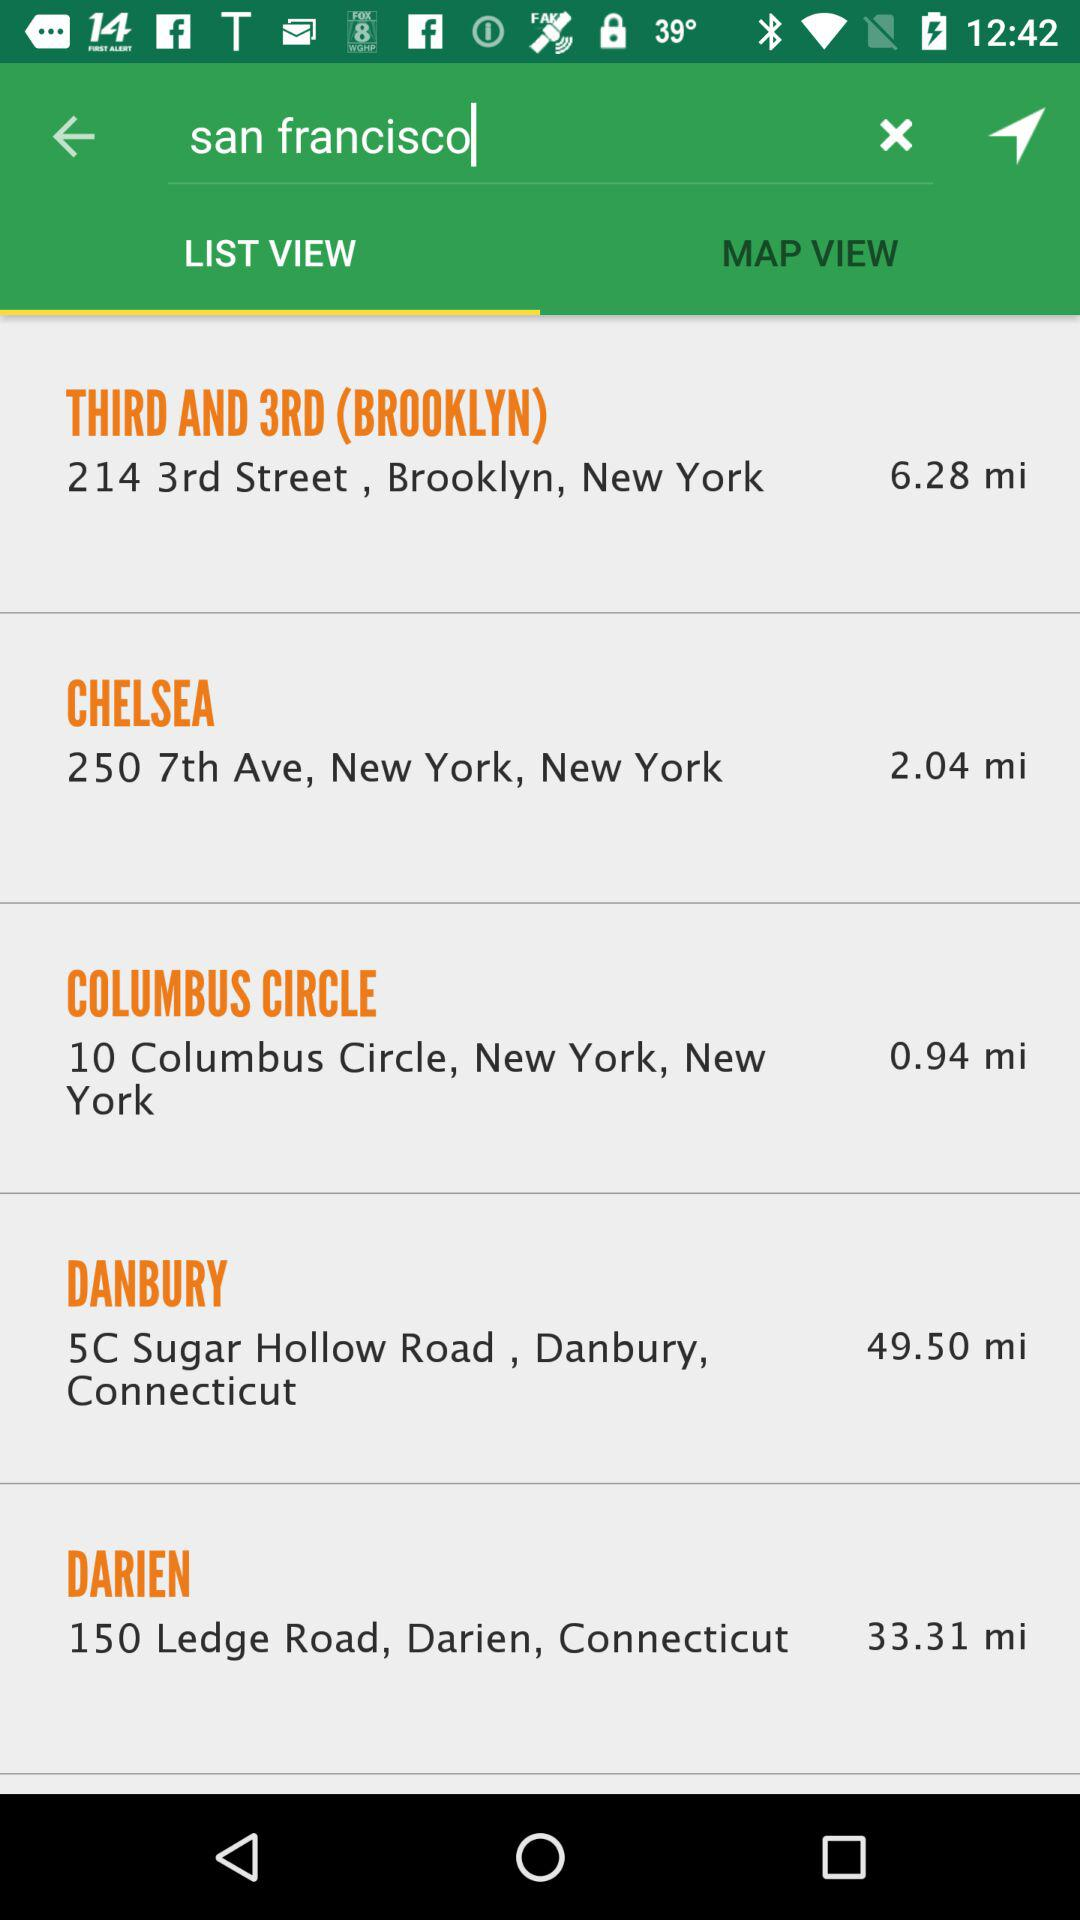What is the address of Chelsea? The address is 250 7th Avenue, New York, New York. 